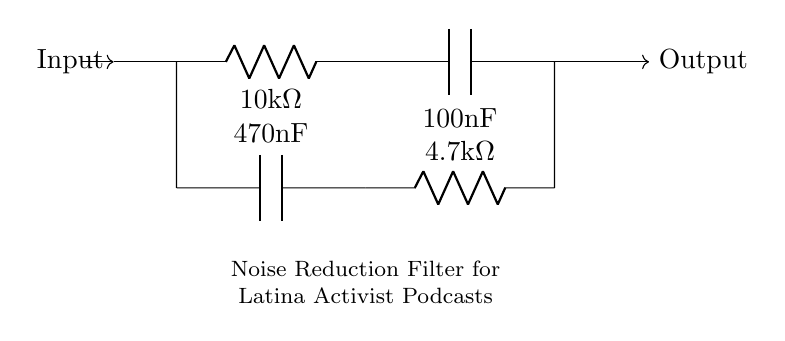What type of filter is represented in this circuit? The circuit diagram depicts a noise reduction filter, which is specifically designed to minimize unwanted sounds in audio systems, making it suitable for podcast audio enhancement.
Answer: noise reduction filter What components are used in the circuit? The circuit uses two resistors (R1 and R2) and two capacitors (C1 and C2), which are key elements in filtering circuits that work together to reduce noise and enhance audio quality.
Answer: two resistors and two capacitors What is the value of R1? The resistor R1 is labeled as 10k ohms in the circuit, indicating its resistance value, which is crucial for determining the filter's performance.
Answer: 10 kilohms How do C1 and C2 affect the filtering process? Capacitors C1 and C2 are used to couple and decouple signals in the circuit, respectively. They play an important role in defining the cutoff frequency of the filter, impacting the audio quality by allowing desired frequencies to pass while blocking unwanted noise.
Answer: they define cutoff frequency What is the total capacitance of the capacitors in the circuit? The total capacitance in parallel can be calculated by adding the values of C1 and C2: 100nF + 470nF = 570nF. This total capacitance affects the filter's frequency response and its ability to reduce noise effectively.
Answer: 570 nanofarads What is the function of R2 in the circuit? Resistor R2 in this circuit affects the filter's gain and helps determine the frequency response characteristics by influencing how signals are attenuated within the filter. This role is crucial for ensuring the audio quality is maintained while unwanted noise is reduced.
Answer: influences gain and frequency response How does this filter improve audio quality for podcasts? The filter reduces background noise and unwanted frequency components from the audio signal, helping to clarify the voices of Latina activists in the podcast. This results in a cleaner audio output that enhances listener engagement and overall experience.
Answer: reduces background noise 